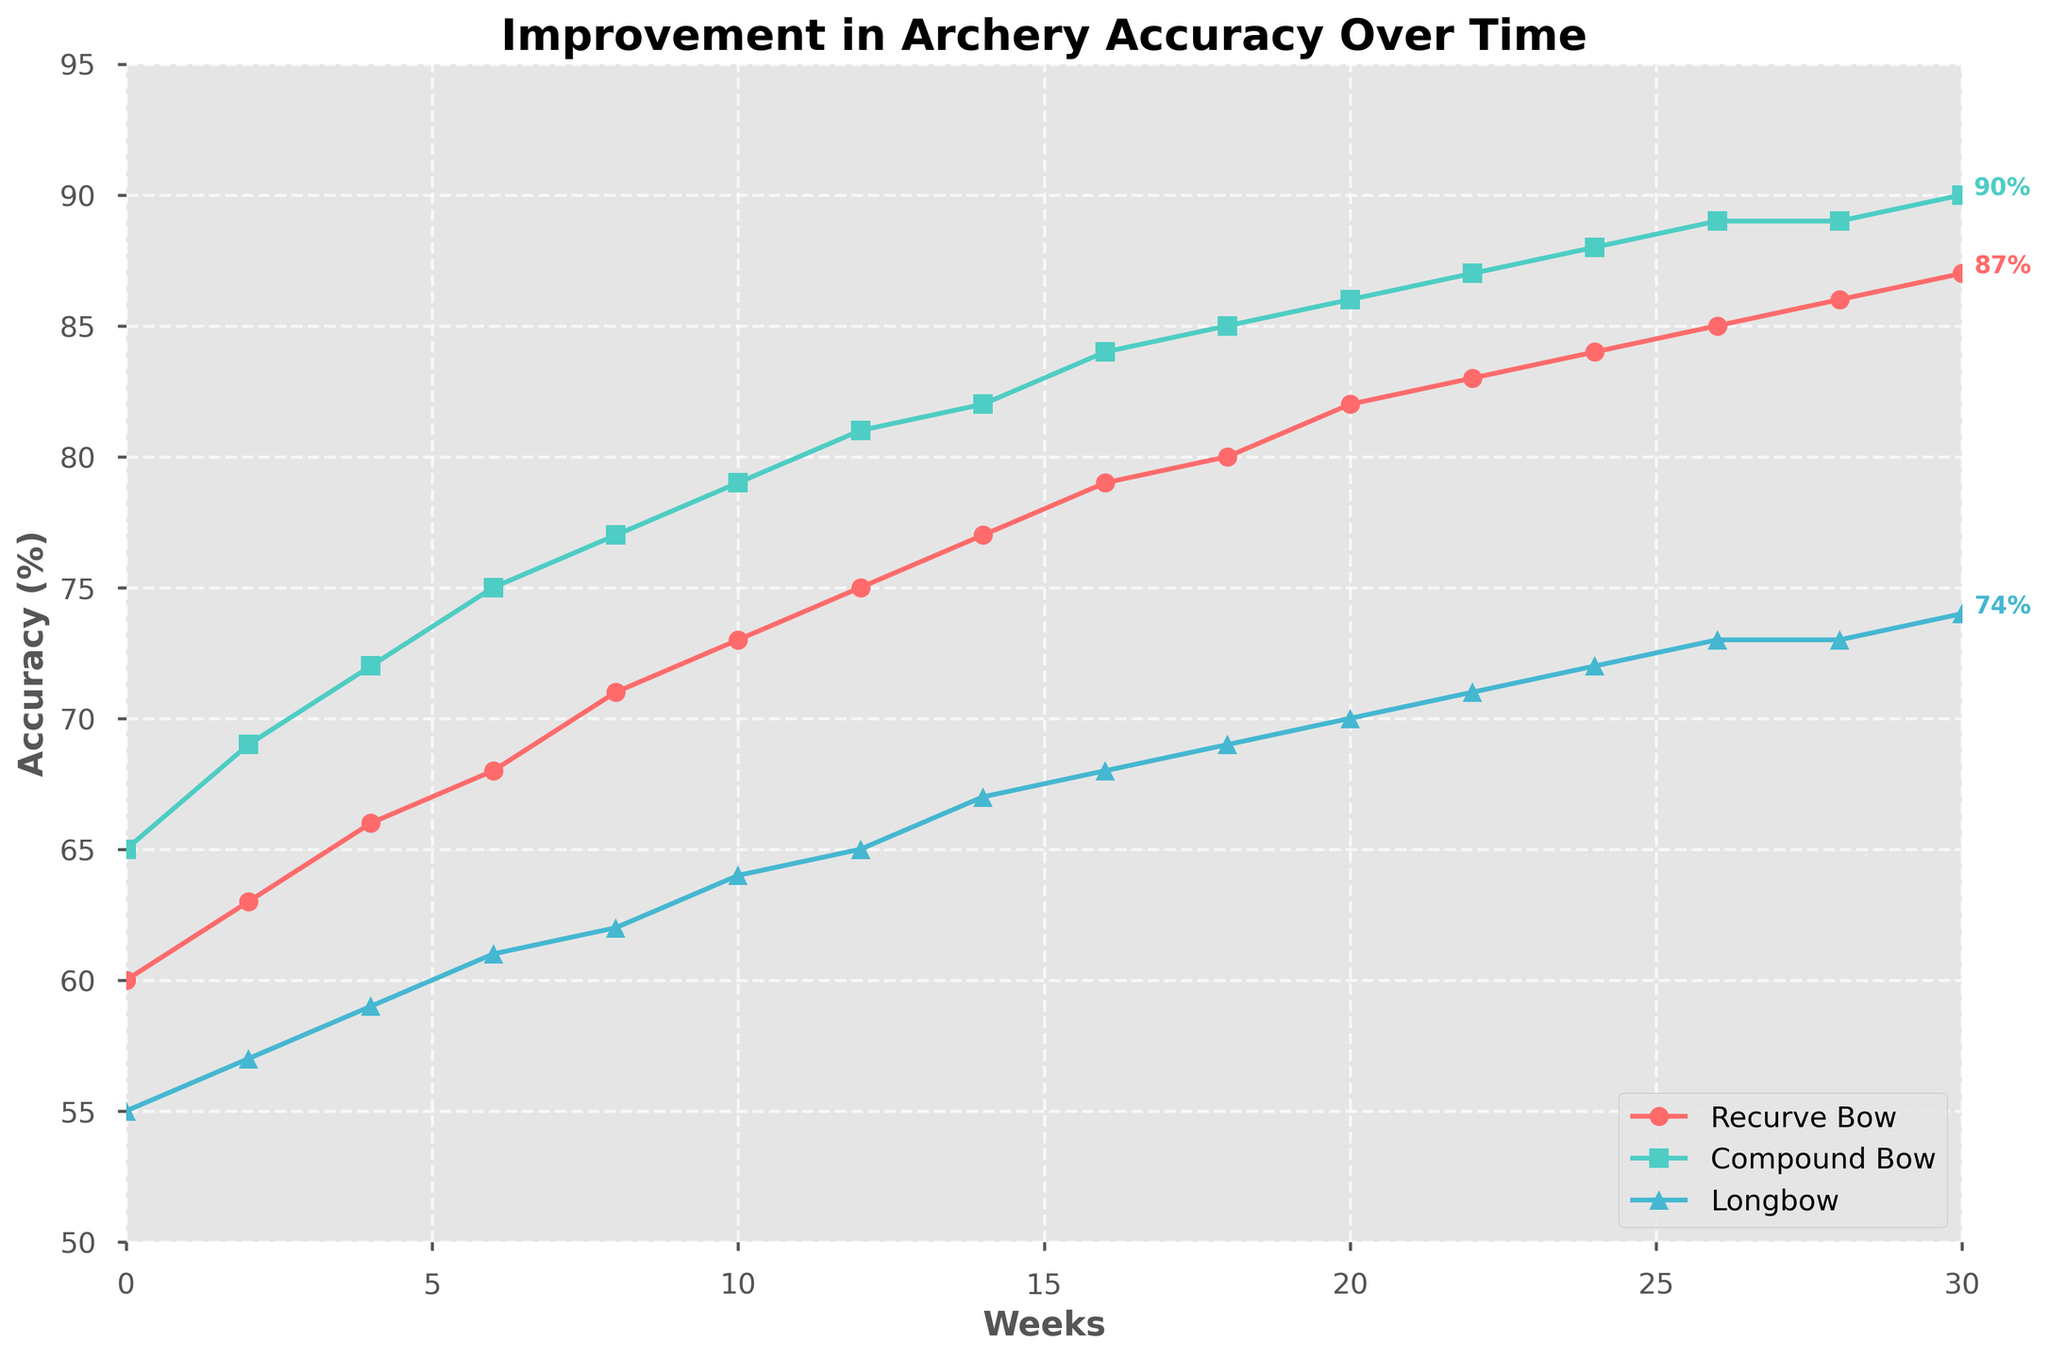Which bow type shows the greatest improvement in accuracy from week 0 to week 30? To find this, subtract the initial accuracy from the final accuracy for each bow type. For recurve bow: 87 - 60 = 27, for compound bow: 90 - 65 = 25, and for longbow: 74 - 55 = 19. The recurve bow shows the greatest improvement.
Answer: Recurve Bow Is the accuracy of the compound bow ever higher than 80%? Scan the compound bow line on the graph. The line crosses the 80% mark between weeks 10 and 12 and remains above 80% afterwards.
Answer: Yes What is the accuracy difference between the recurve bow and longbow at week 20? Check the values at week 20 for both recurve bow (82) and longbow (70) and subtract them: 82 - 70 = 12.
Answer: 12% Which bow reaches 85% accuracy first? Analyze the figure and identify which line reaches 85% first. The compound bow hits 85% between week 18 and 20, while other bows do not reach this mark until later.
Answer: Compound Bow How many weeks did it take for the longbow to surpass 60% accuracy? Locate the point where the longbow line crosses 60%. This occurs between weeks 6 and 8.
Answer: Between 6 and 8 weeks Which bow type has the steepest increase in accuracy from week 0 to week 6? Calculate the increase for each bow in the first 6 weeks: recurve bow: 68 - 60 = 8, compound bow: 75 - 65 = 10, longbow: 61 - 55 = 6. The compound bow shows the steepest increase.
Answer: Compound Bow Was there any week where the longbow had a higher accuracy than the recurve bow? Visually examine the lines representing longbow and recurve bow across the graph. The longbow line is always below the recurve bow line, indicating it never surpasses it in accuracy.
Answer: No On average, how much did the accuracy improve per week for the compound bow over the 30 weeks? Divide the total improvement by the number of weeks: (90 - 65) / 30 = 25 / 30 = 0.83% per week.
Answer: 0.83% per week 